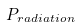Convert formula to latex. <formula><loc_0><loc_0><loc_500><loc_500>P _ { r a d i a t i o n }</formula> 